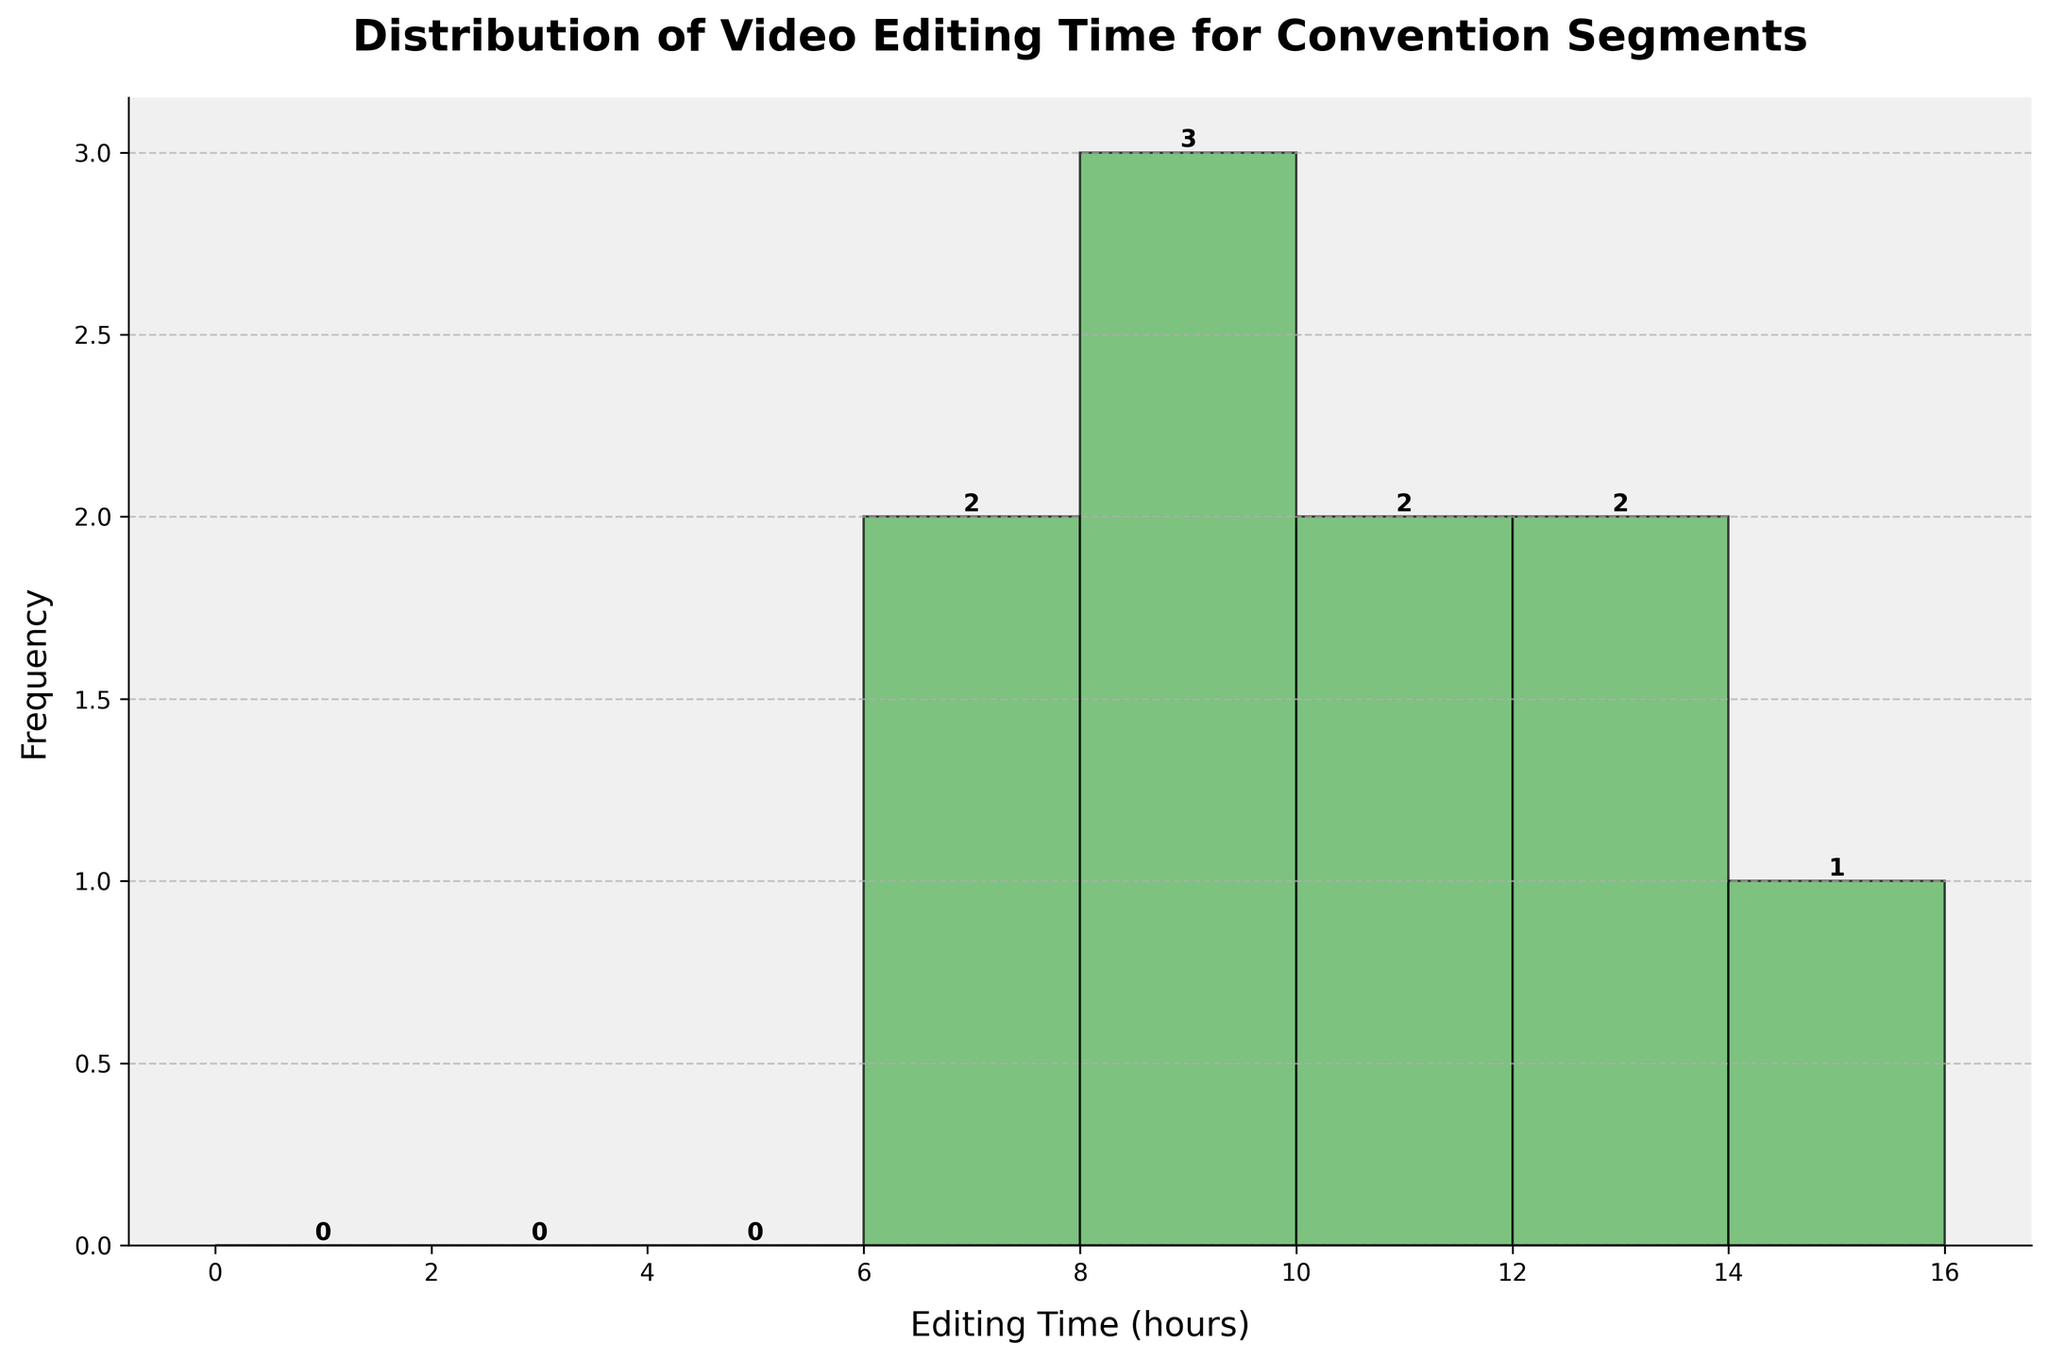What is the title of the histogram? The title is usually found at the top of the graph. It describes the content or the purpose of the graph. In this case, it mentions the theme and context of the histogram directly.
Answer: Distribution of Video Editing Time for Convention Segments What is the most common editing time range? Look for the tallest bar in the histogram, as it represents the range where the most data points fall.
Answer: 6-8 hours How many segments required between 6 and 8 hours of editing? Find the tallest bar which represents the range 6-8 hours and check the label above the bar for frequency.
Answer: 3 segments Which editing time range has the fewest segments? Look for the shortest bar in the histogram, as it represents the range with the least data points.
Answer: 14-16 hours What is the range of editing times displayed on the x-axis? Check the x-axis labels to determine the range of values included in the histogram.
Answer: 0-16 hours How many segments needed more than 10 hours of editing? Add up the frequencies of all segments that fall within the editing time ranges greater than 10 hours.
Answer: 3 segments Which range contains exactly 2 segments? Identify the bar with a frequency of 2 and check the corresponding x-axis range for that bar.
Answer: 10-12 hours How many hours are the mode editing time, the value that appears most frequently? Determine the peak of the histogram and locate the corresponding editing time on the x-axis that holds the highest frequency.
Answer: 8 hours What is the total number of segments shown in the histogram? Sum the frequencies of all the bars to get the total count of segments.
Answer: 10 segments What is the mean (average) editing time for the segments? Add up all the editing times and then divide by the total number of segments.
Answer: (8 + 12 + 15 + 10 + 6 + 9 + 7 + 11 + 13 + 8) / 10 = 9.9 hours 